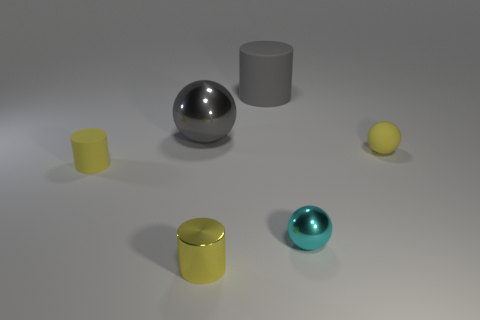Add 2 yellow things. How many objects exist? 8 Add 1 large red matte things. How many large red matte things exist? 1 Subtract 0 red blocks. How many objects are left? 6 Subtract all tiny things. Subtract all red blocks. How many objects are left? 2 Add 3 large gray matte things. How many large gray matte things are left? 4 